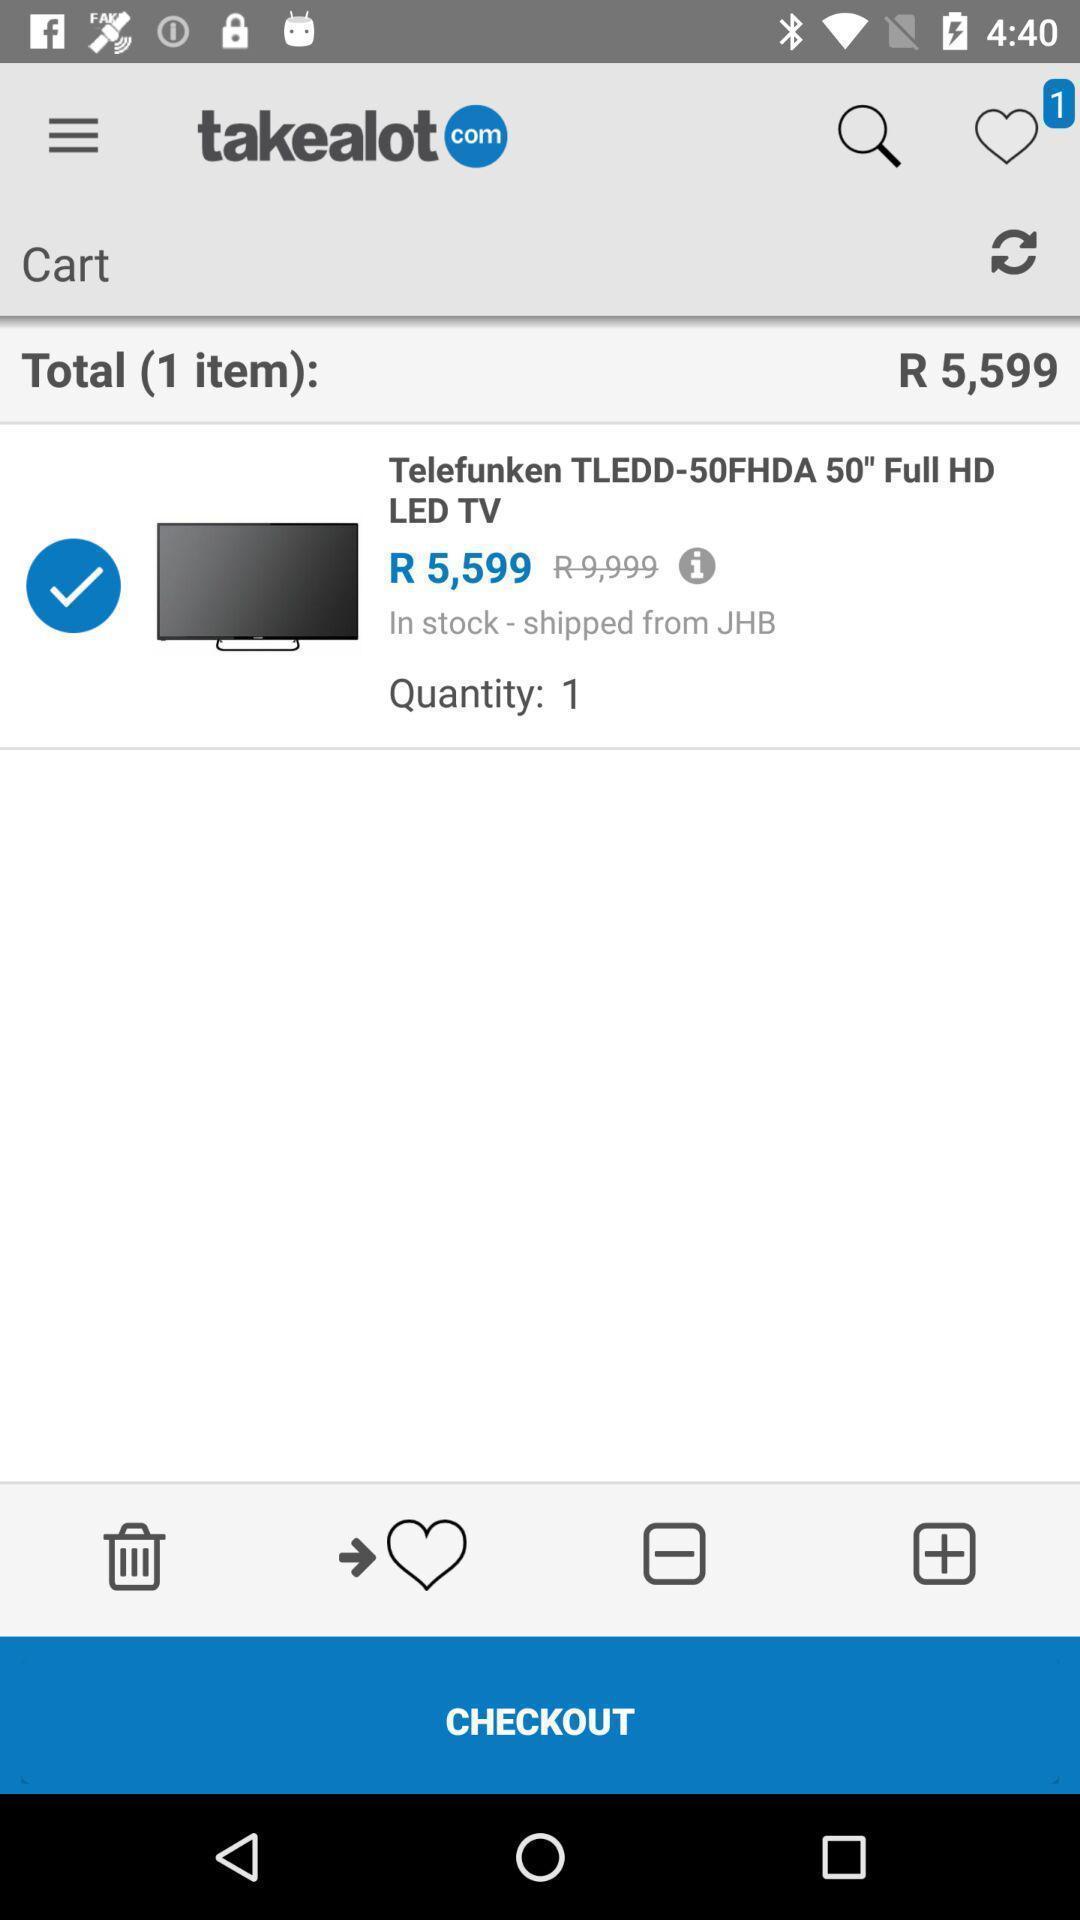Give me a summary of this screen capture. Page showing few options and information in shopping app. 